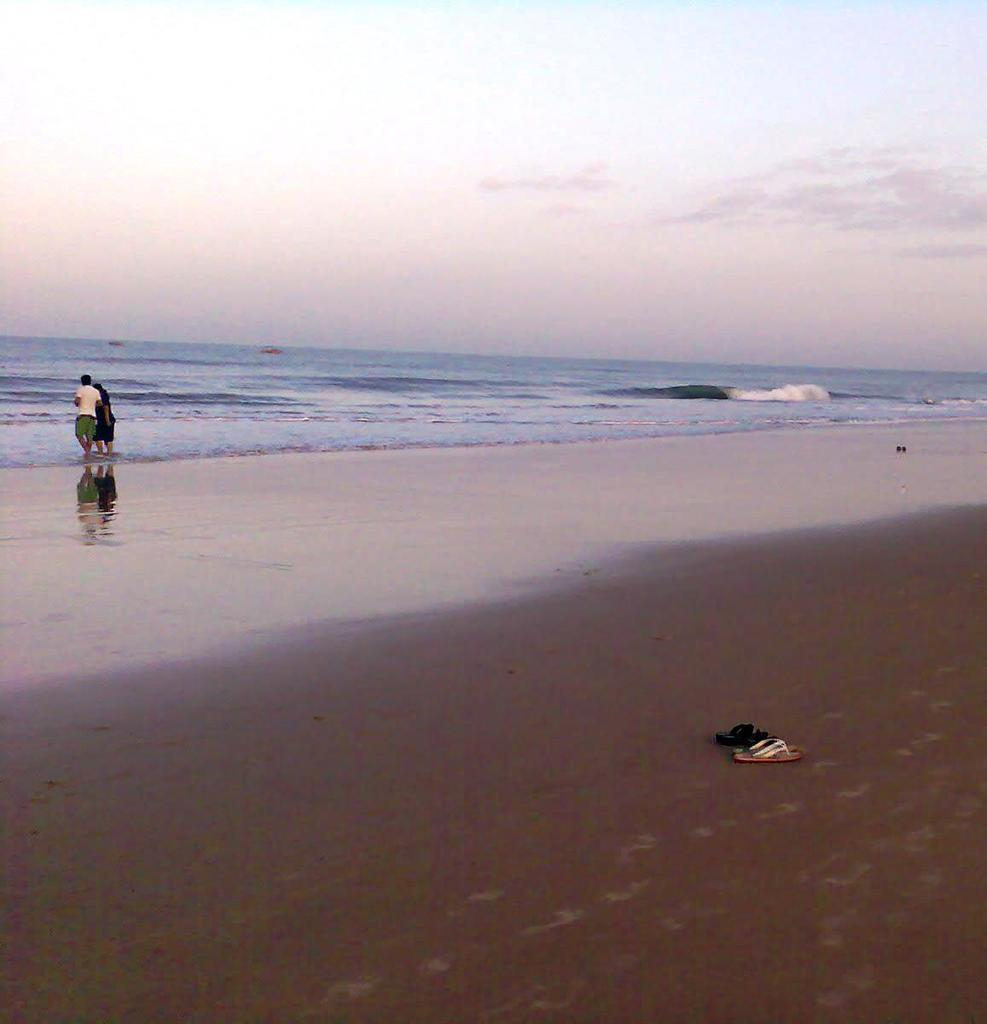What can be seen in the image in terms of people? There are humans standing in the image. What objects are present on the shore? There are two pairs of footwear on the shore. What natural element is visible in the image? There is water visible in the image. How would you describe the sky in the image? The sky appears to be cloudy. Is there a girl wearing a mask in the image? There is no girl or mask present in the image. 